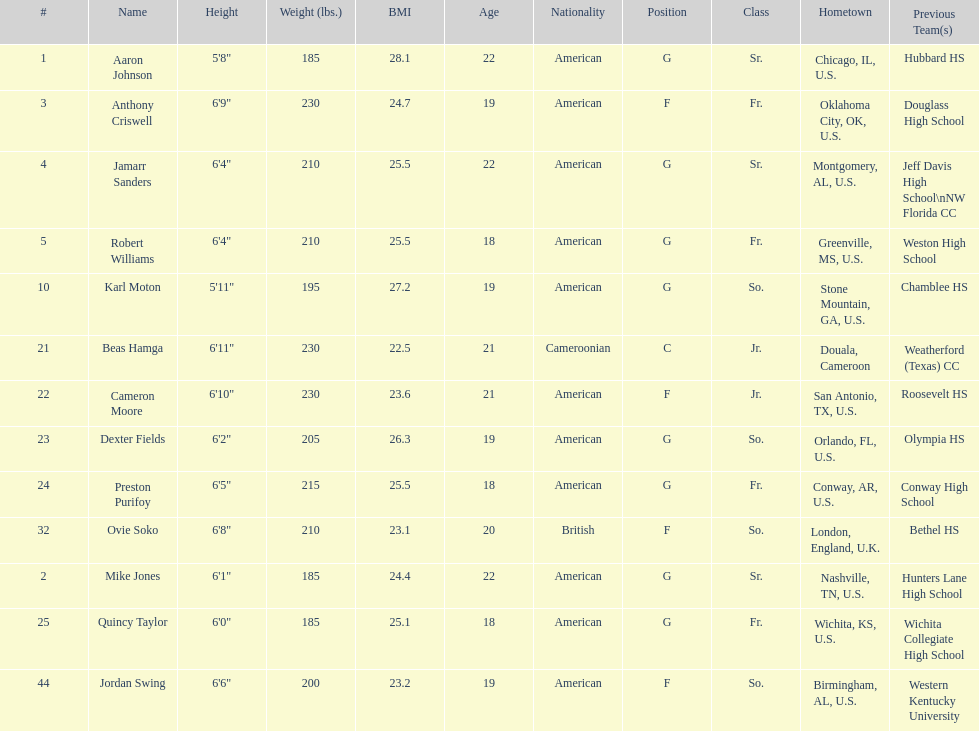What is the average weight of jamarr sanders and robert williams? 210. 